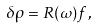Convert formula to latex. <formula><loc_0><loc_0><loc_500><loc_500>\delta \rho = R ( \omega ) f ,</formula> 